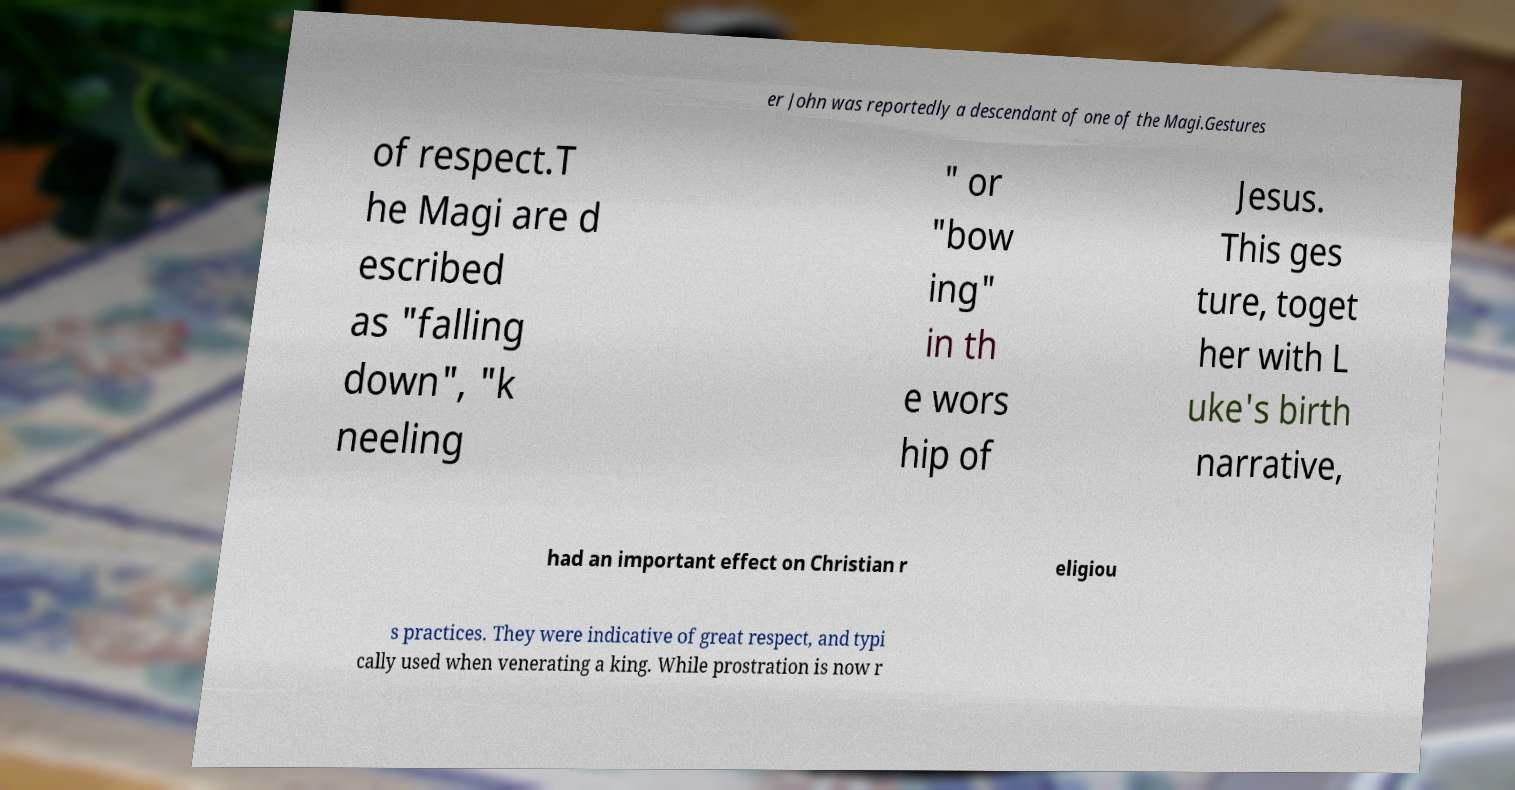I need the written content from this picture converted into text. Can you do that? er John was reportedly a descendant of one of the Magi.Gestures of respect.T he Magi are d escribed as "falling down", "k neeling " or "bow ing" in th e wors hip of Jesus. This ges ture, toget her with L uke's birth narrative, had an important effect on Christian r eligiou s practices. They were indicative of great respect, and typi cally used when venerating a king. While prostration is now r 